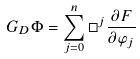<formula> <loc_0><loc_0><loc_500><loc_500>G _ { D } \Phi = \sum _ { j = 0 } ^ { n } \Box ^ { j } \frac { \partial F } { \partial \varphi _ { j } }</formula> 